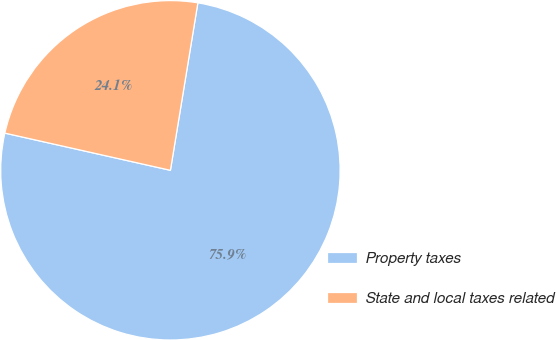<chart> <loc_0><loc_0><loc_500><loc_500><pie_chart><fcel>Property taxes<fcel>State and local taxes related<nl><fcel>75.93%<fcel>24.07%<nl></chart> 